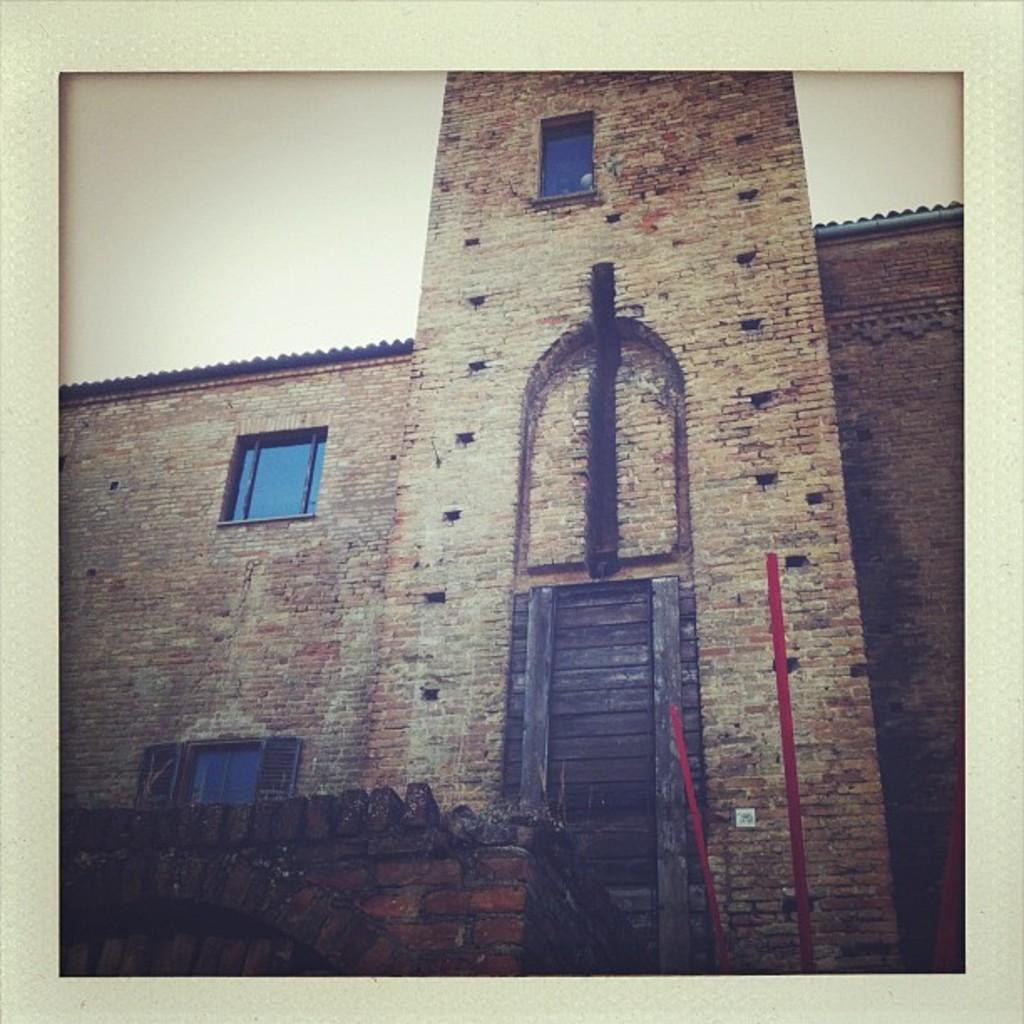What can be said about the nature of the image? The image is edited. What type of structure is present in the image? There is a building in the image. What material is the building made of? The building is made up of bricks. How many windows of the building can be seen in the image? There are three windows of the building visible in the image. What type of clouds can be seen in the image? There are no clouds visible in the image, as the focus is on the building and its windows. How does the process of digestion relate to the image? The process of digestion is not related to the image, as it features a building with bricks and windows. 